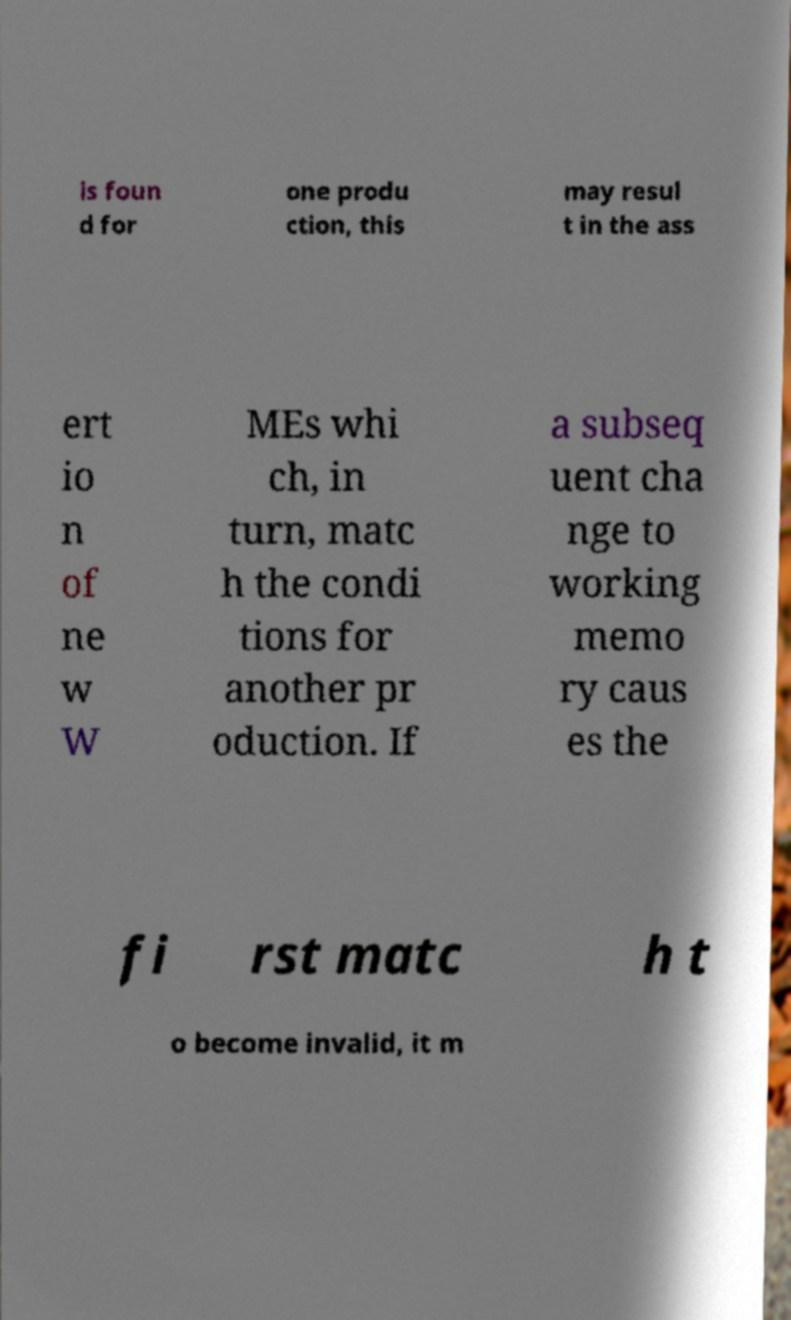Can you accurately transcribe the text from the provided image for me? is foun d for one produ ction, this may resul t in the ass ert io n of ne w W MEs whi ch, in turn, matc h the condi tions for another pr oduction. If a subseq uent cha nge to working memo ry caus es the fi rst matc h t o become invalid, it m 